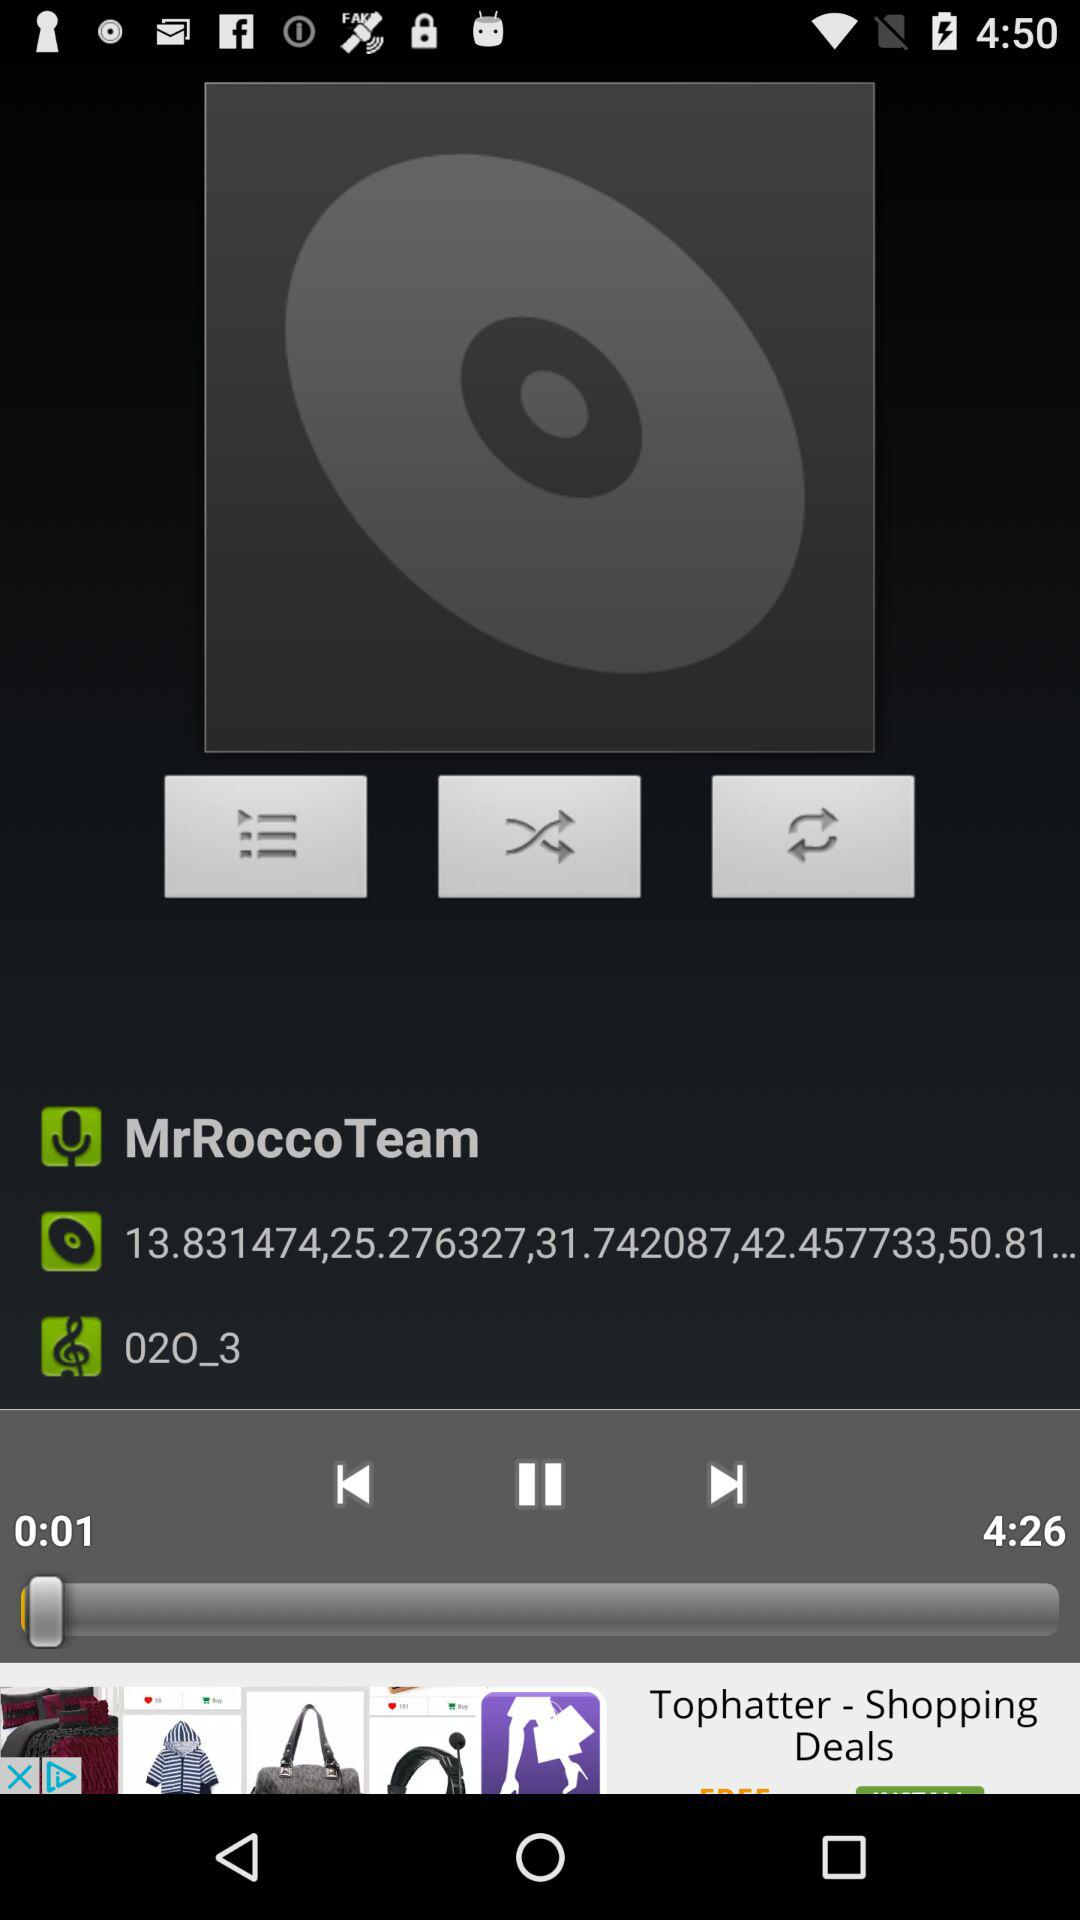For how long has the audio been played? The audio has been played for 1 second. 